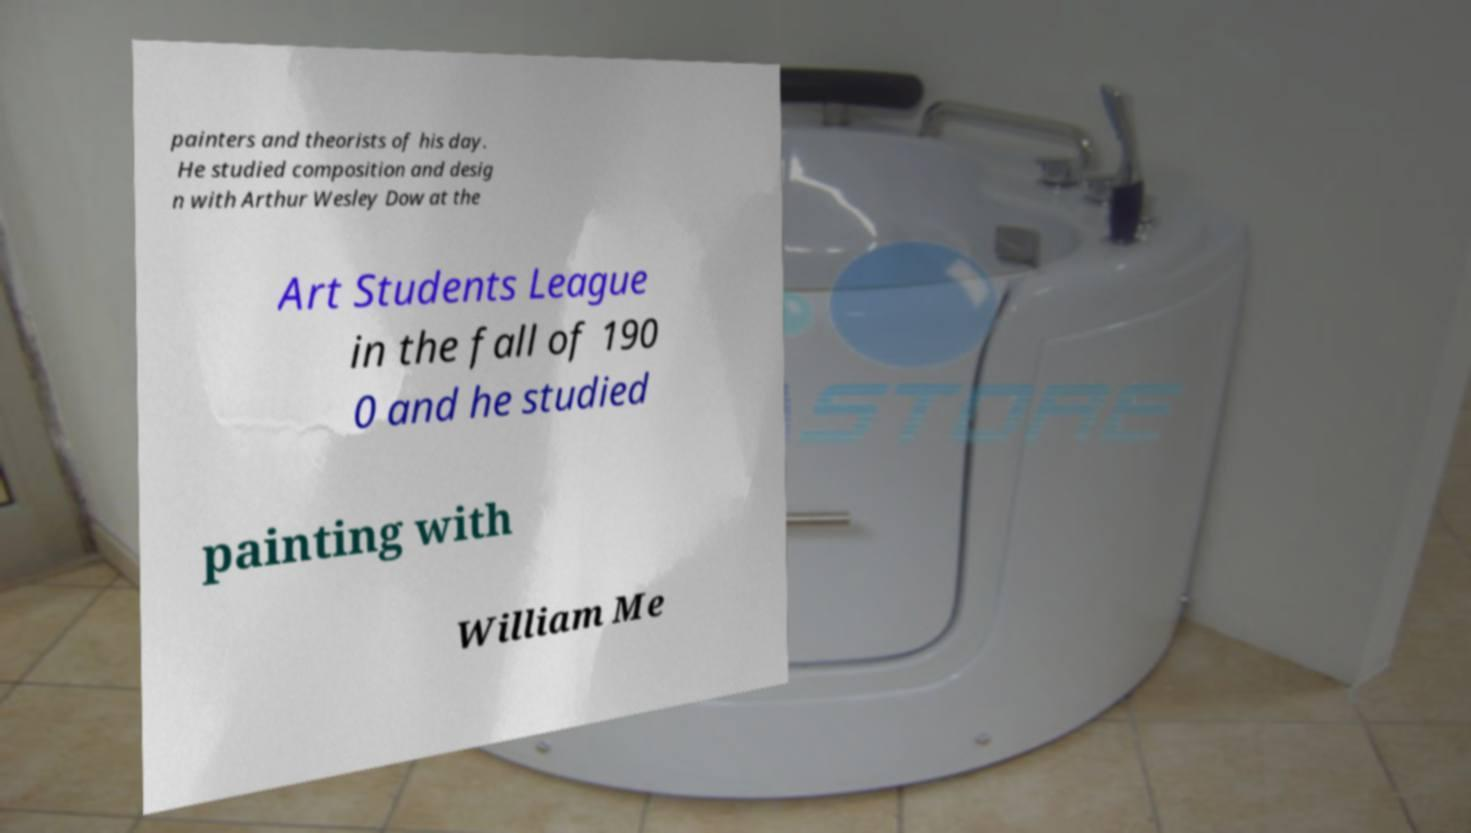For documentation purposes, I need the text within this image transcribed. Could you provide that? painters and theorists of his day. He studied composition and desig n with Arthur Wesley Dow at the Art Students League in the fall of 190 0 and he studied painting with William Me 